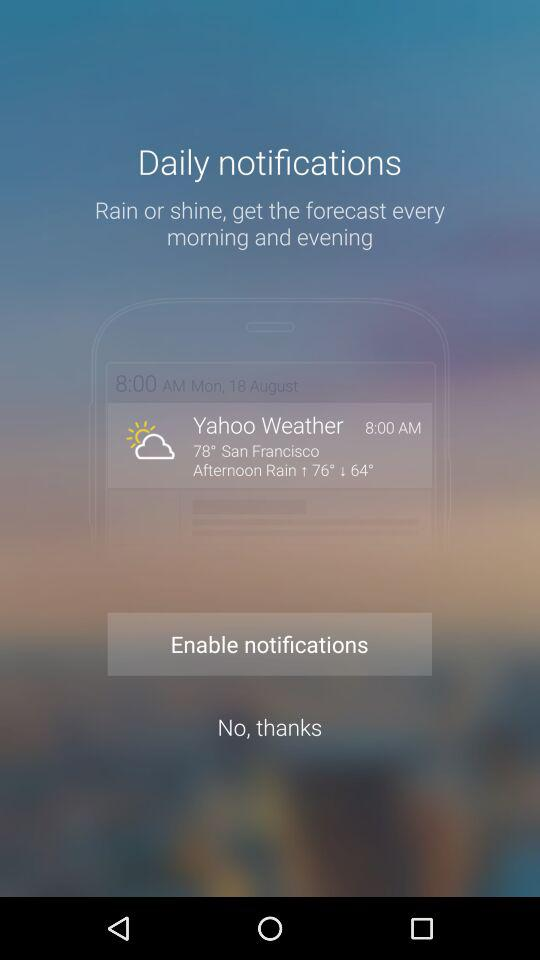What is the temperature? The temperature is 78°. 